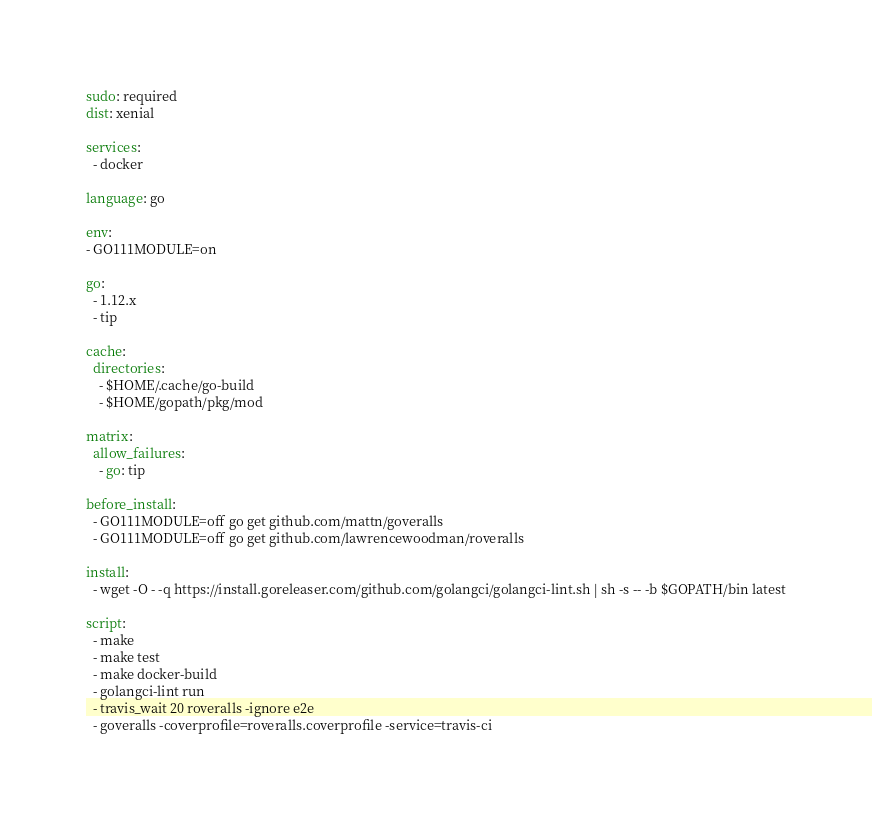Convert code to text. <code><loc_0><loc_0><loc_500><loc_500><_YAML_>sudo: required
dist: xenial

services:
  - docker

language: go

env:
- GO111MODULE=on

go:
  - 1.12.x
  - tip

cache:
  directories:
    - $HOME/.cache/go-build
    - $HOME/gopath/pkg/mod

matrix:
  allow_failures:
    - go: tip

before_install:
  - GO111MODULE=off go get github.com/mattn/goveralls
  - GO111MODULE=off go get github.com/lawrencewoodman/roveralls

install:
  - wget -O - -q https://install.goreleaser.com/github.com/golangci/golangci-lint.sh | sh -s -- -b $GOPATH/bin latest

script:
  - make
  - make test
  - make docker-build
  - golangci-lint run
  - travis_wait 20 roveralls -ignore e2e
  - goveralls -coverprofile=roveralls.coverprofile -service=travis-ci
</code> 